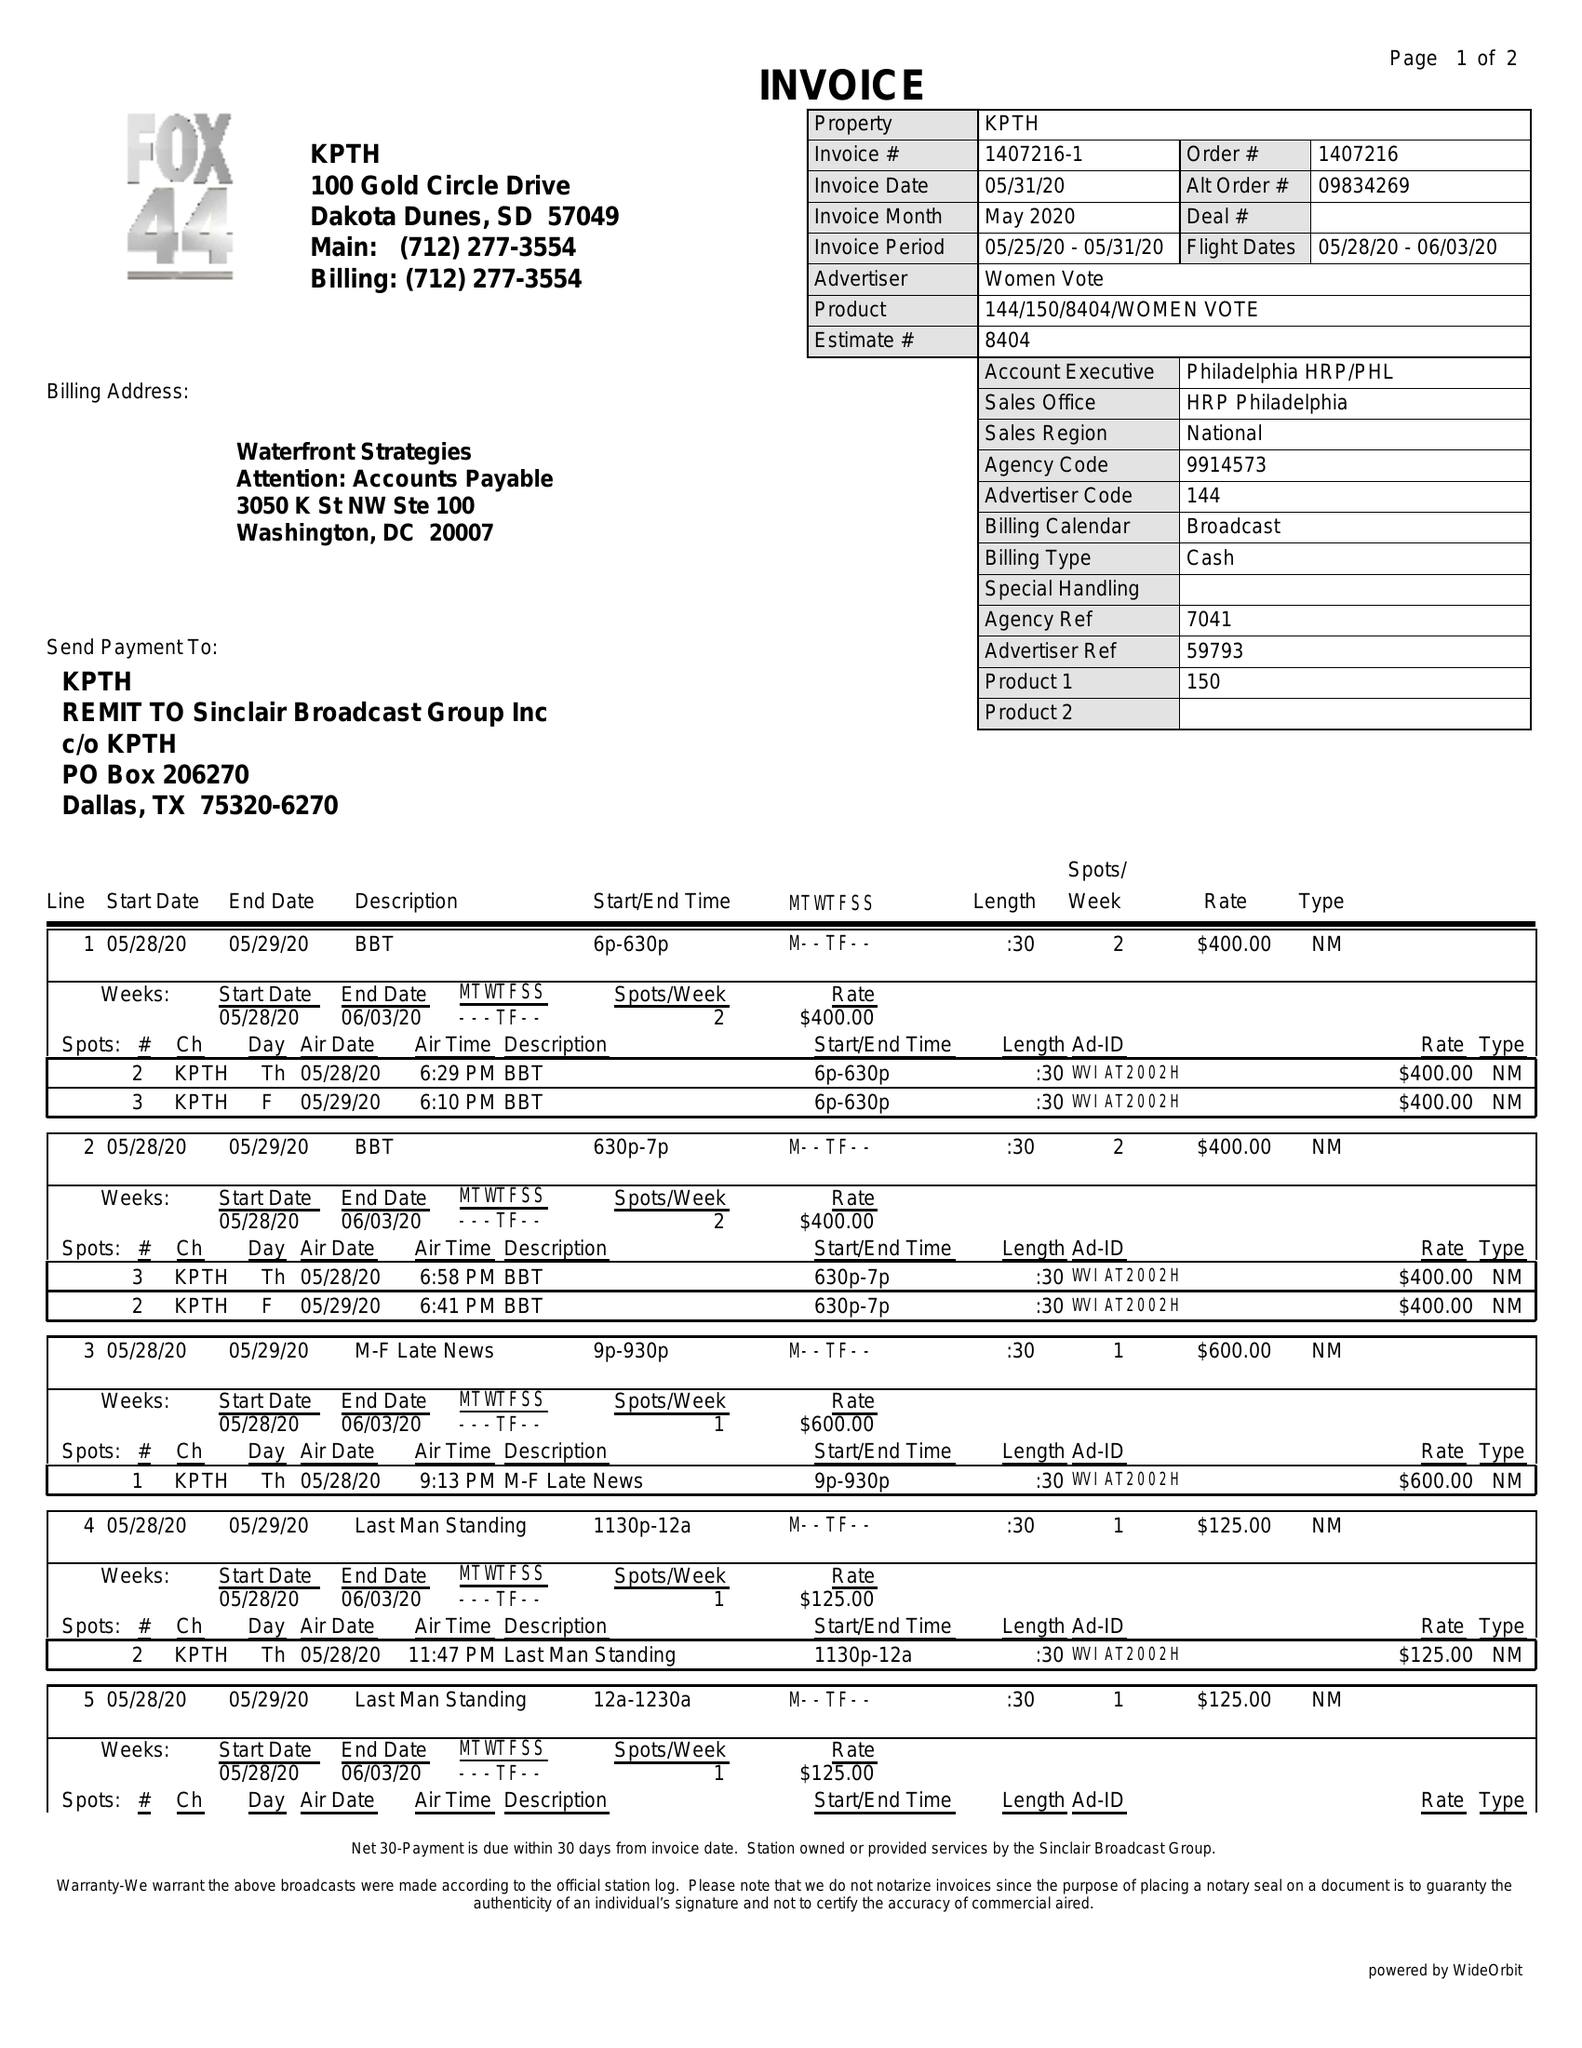What is the value for the gross_amount?
Answer the question using a single word or phrase. 3050.00 